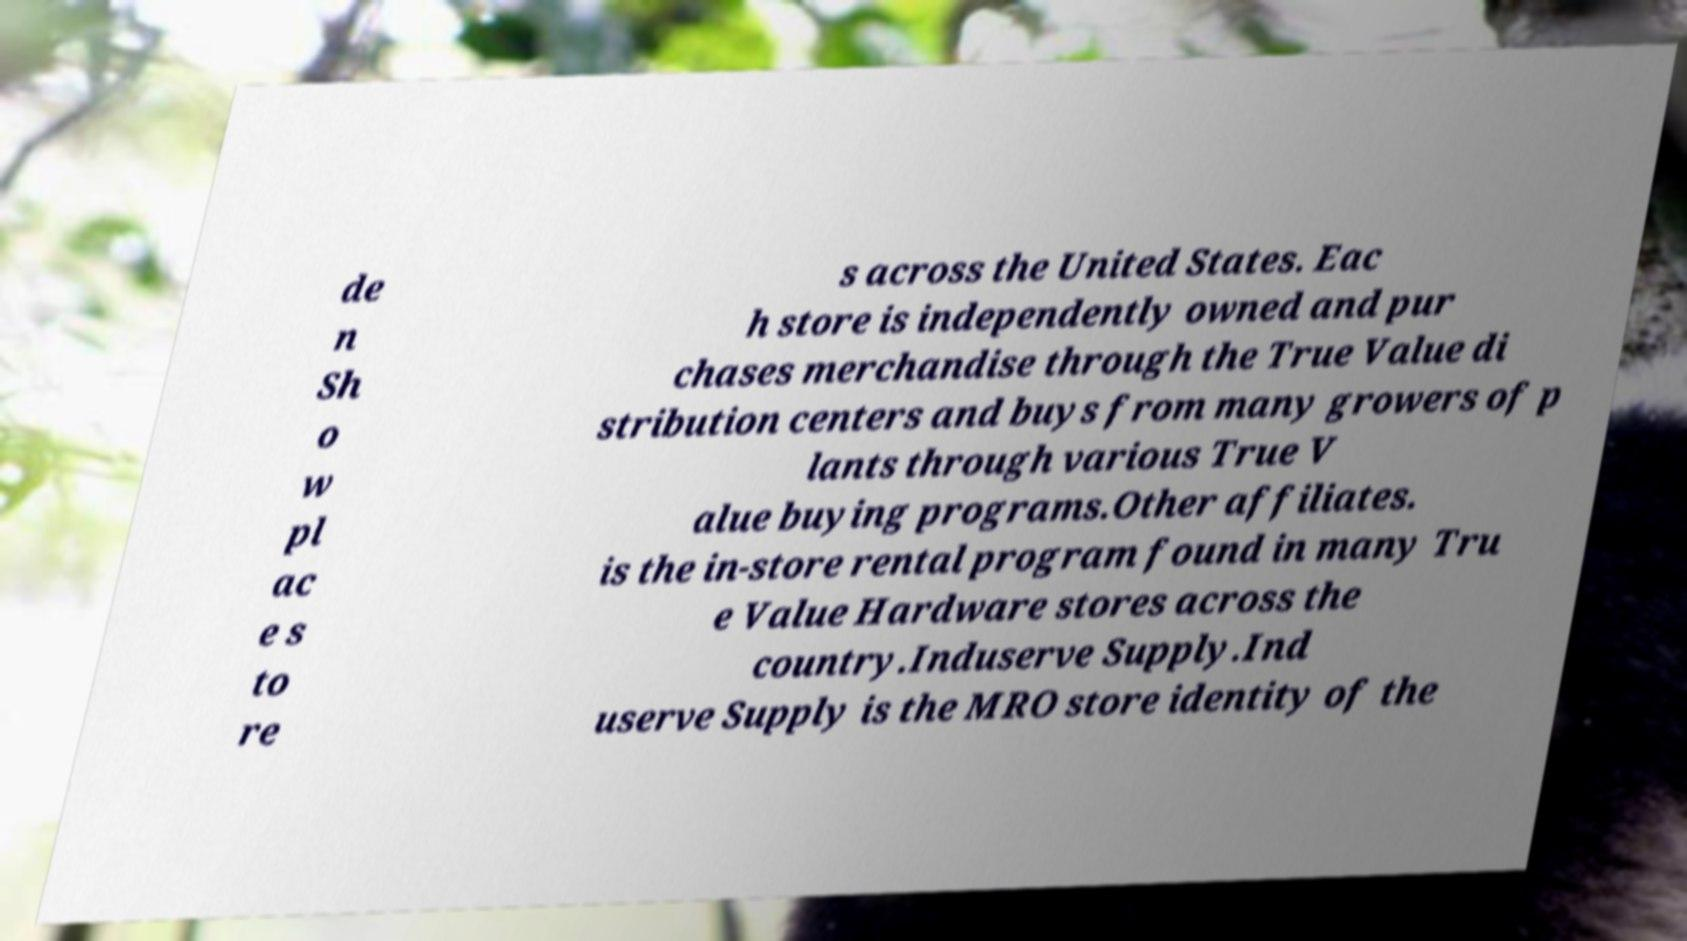There's text embedded in this image that I need extracted. Can you transcribe it verbatim? de n Sh o w pl ac e s to re s across the United States. Eac h store is independently owned and pur chases merchandise through the True Value di stribution centers and buys from many growers of p lants through various True V alue buying programs.Other affiliates. is the in-store rental program found in many Tru e Value Hardware stores across the country.Induserve Supply.Ind userve Supply is the MRO store identity of the 